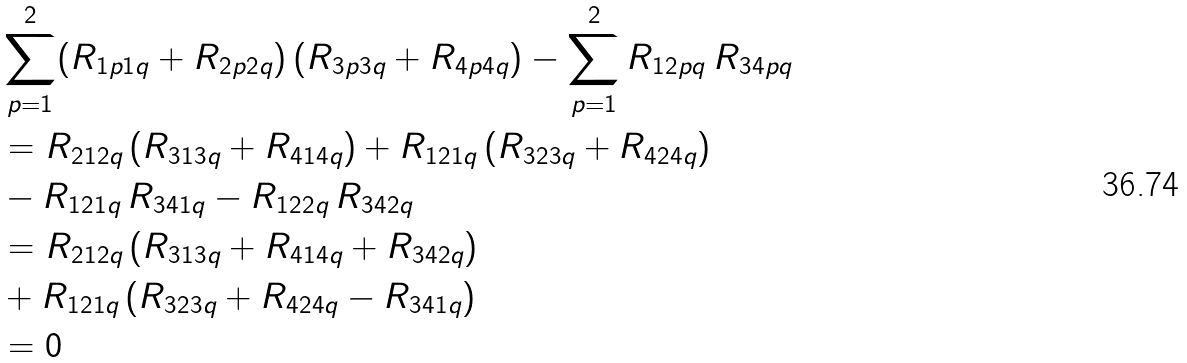<formula> <loc_0><loc_0><loc_500><loc_500>& \sum _ { p = 1 } ^ { 2 } ( R _ { 1 p 1 q } + R _ { 2 p 2 q } ) \, ( R _ { 3 p 3 q } + R _ { 4 p 4 q } ) - \sum _ { p = 1 } ^ { 2 } R _ { 1 2 p q } \, R _ { 3 4 p q } \\ & = R _ { 2 1 2 q } \, ( R _ { 3 1 3 q } + R _ { 4 1 4 q } ) + R _ { 1 2 1 q } \, ( R _ { 3 2 3 q } + R _ { 4 2 4 q } ) \\ & - R _ { 1 2 1 q } \, R _ { 3 4 1 q } - R _ { 1 2 2 q } \, R _ { 3 4 2 q } \\ & = R _ { 2 1 2 q } \, ( R _ { 3 1 3 q } + R _ { 4 1 4 q } + R _ { 3 4 2 q } ) \\ & + R _ { 1 2 1 q } \, ( R _ { 3 2 3 q } + R _ { 4 2 4 q } - R _ { 3 4 1 q } ) \\ & = 0</formula> 